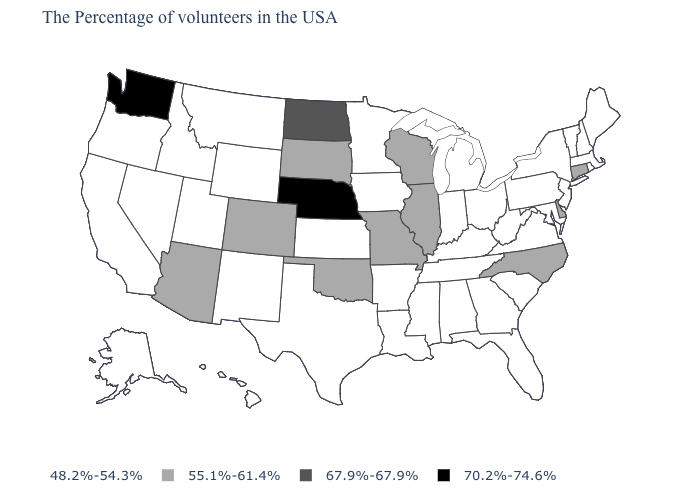Among the states that border Montana , which have the lowest value?
Write a very short answer. Wyoming, Idaho. Does Ohio have the highest value in the MidWest?
Be succinct. No. Which states have the lowest value in the MidWest?
Short answer required. Ohio, Michigan, Indiana, Minnesota, Iowa, Kansas. What is the value of Delaware?
Quick response, please. 55.1%-61.4%. Does Delaware have the highest value in the South?
Write a very short answer. Yes. What is the value of Ohio?
Answer briefly. 48.2%-54.3%. Name the states that have a value in the range 48.2%-54.3%?
Keep it brief. Maine, Massachusetts, Rhode Island, New Hampshire, Vermont, New York, New Jersey, Maryland, Pennsylvania, Virginia, South Carolina, West Virginia, Ohio, Florida, Georgia, Michigan, Kentucky, Indiana, Alabama, Tennessee, Mississippi, Louisiana, Arkansas, Minnesota, Iowa, Kansas, Texas, Wyoming, New Mexico, Utah, Montana, Idaho, Nevada, California, Oregon, Alaska, Hawaii. Which states have the lowest value in the South?
Quick response, please. Maryland, Virginia, South Carolina, West Virginia, Florida, Georgia, Kentucky, Alabama, Tennessee, Mississippi, Louisiana, Arkansas, Texas. Does the map have missing data?
Keep it brief. No. What is the value of Nevada?
Give a very brief answer. 48.2%-54.3%. What is the lowest value in states that border South Dakota?
Keep it brief. 48.2%-54.3%. What is the value of Wyoming?
Concise answer only. 48.2%-54.3%. What is the value of Connecticut?
Be succinct. 55.1%-61.4%. Which states have the lowest value in the South?
Be succinct. Maryland, Virginia, South Carolina, West Virginia, Florida, Georgia, Kentucky, Alabama, Tennessee, Mississippi, Louisiana, Arkansas, Texas. Which states have the lowest value in the USA?
Answer briefly. Maine, Massachusetts, Rhode Island, New Hampshire, Vermont, New York, New Jersey, Maryland, Pennsylvania, Virginia, South Carolina, West Virginia, Ohio, Florida, Georgia, Michigan, Kentucky, Indiana, Alabama, Tennessee, Mississippi, Louisiana, Arkansas, Minnesota, Iowa, Kansas, Texas, Wyoming, New Mexico, Utah, Montana, Idaho, Nevada, California, Oregon, Alaska, Hawaii. 